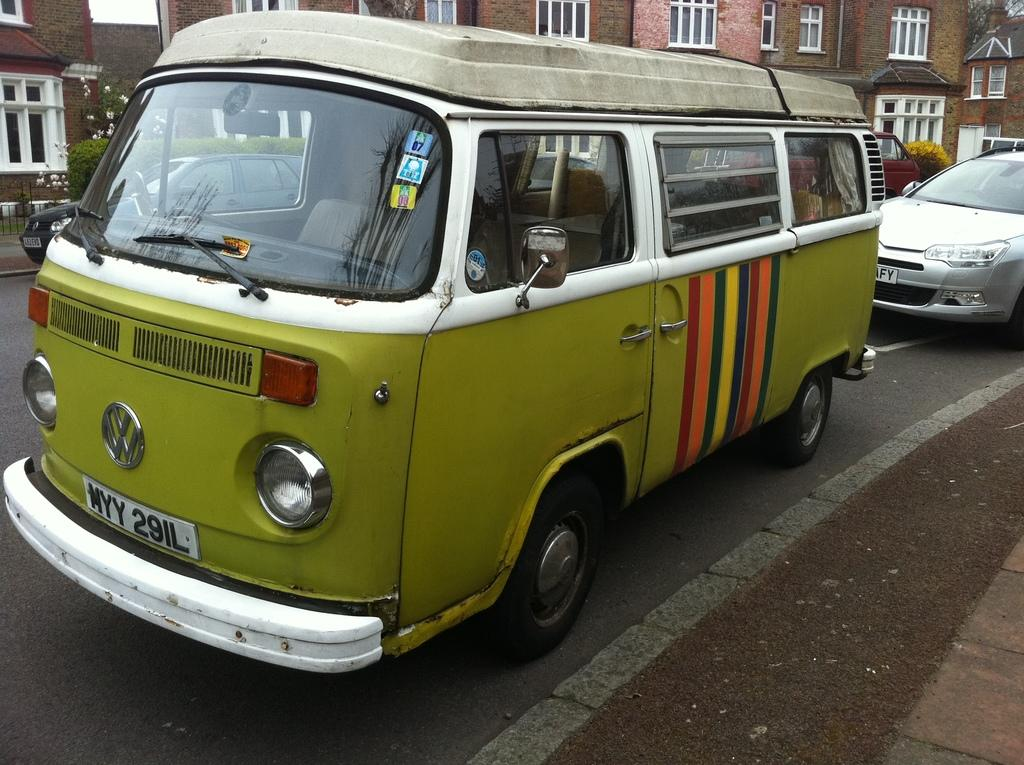What can be seen on the road in the image? There are vehicles on the road in the image. What is visible in the background of the image? There are trees, buildings, and a fence in the background of the image. Are there any plants or flowers in the image? Yes, flowers are present in the image. What invention is being demonstrated in the image? There is no invention being demonstrated in the image; it features vehicles on the road, trees, buildings, a fence, and flowers. How many clovers can be seen growing in the image? There is no mention of clovers in the image; it features flowers, but the specific type of flowers is not specified. 